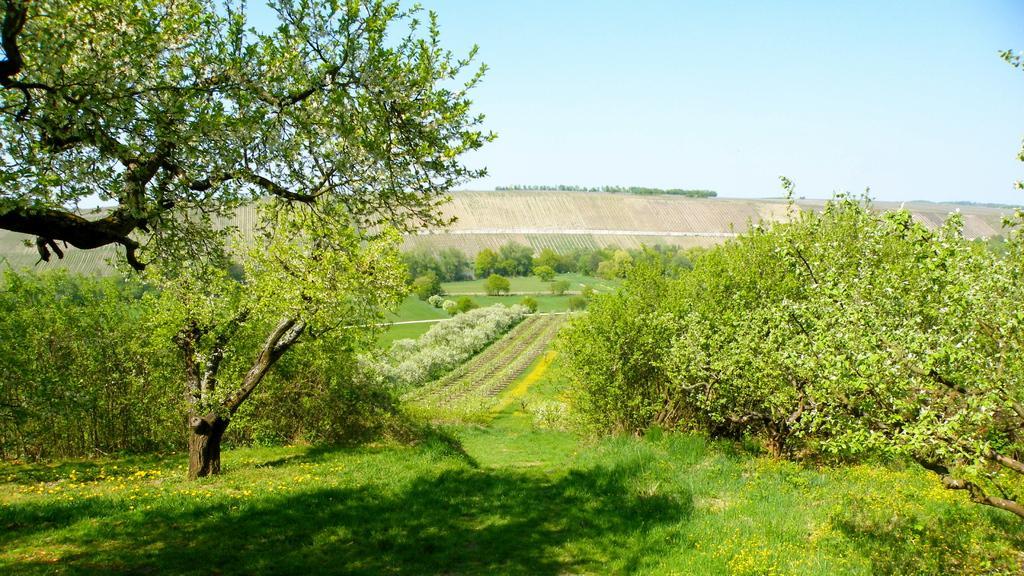Please provide a concise description of this image. In this picture we can see grass and few trees. 